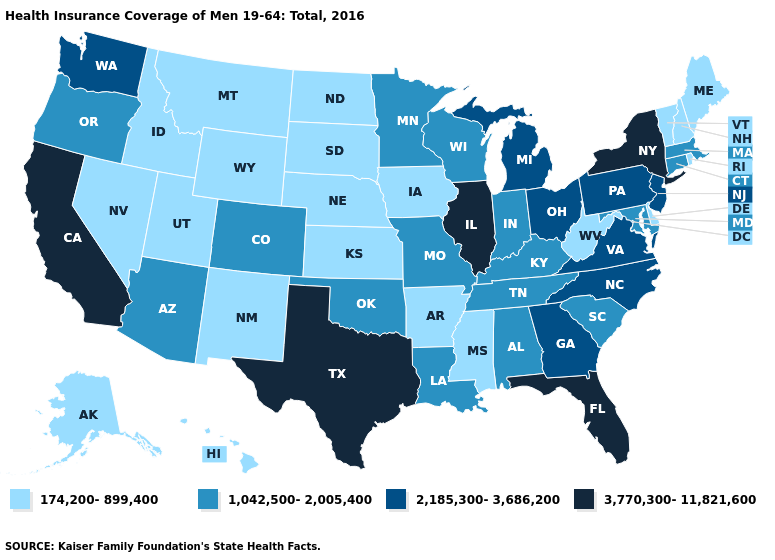Which states have the highest value in the USA?
Write a very short answer. California, Florida, Illinois, New York, Texas. What is the lowest value in the MidWest?
Short answer required. 174,200-899,400. Name the states that have a value in the range 3,770,300-11,821,600?
Concise answer only. California, Florida, Illinois, New York, Texas. What is the value of Colorado?
Be succinct. 1,042,500-2,005,400. What is the value of Montana?
Quick response, please. 174,200-899,400. What is the value of Arizona?
Write a very short answer. 1,042,500-2,005,400. Which states hav the highest value in the West?
Quick response, please. California. Name the states that have a value in the range 2,185,300-3,686,200?
Concise answer only. Georgia, Michigan, New Jersey, North Carolina, Ohio, Pennsylvania, Virginia, Washington. Does North Dakota have a lower value than Kansas?
Concise answer only. No. Name the states that have a value in the range 1,042,500-2,005,400?
Give a very brief answer. Alabama, Arizona, Colorado, Connecticut, Indiana, Kentucky, Louisiana, Maryland, Massachusetts, Minnesota, Missouri, Oklahoma, Oregon, South Carolina, Tennessee, Wisconsin. Name the states that have a value in the range 174,200-899,400?
Write a very short answer. Alaska, Arkansas, Delaware, Hawaii, Idaho, Iowa, Kansas, Maine, Mississippi, Montana, Nebraska, Nevada, New Hampshire, New Mexico, North Dakota, Rhode Island, South Dakota, Utah, Vermont, West Virginia, Wyoming. Name the states that have a value in the range 3,770,300-11,821,600?
Quick response, please. California, Florida, Illinois, New York, Texas. What is the highest value in states that border Michigan?
Quick response, please. 2,185,300-3,686,200. Does Missouri have the same value as Arkansas?
Quick response, please. No. What is the highest value in the MidWest ?
Write a very short answer. 3,770,300-11,821,600. 